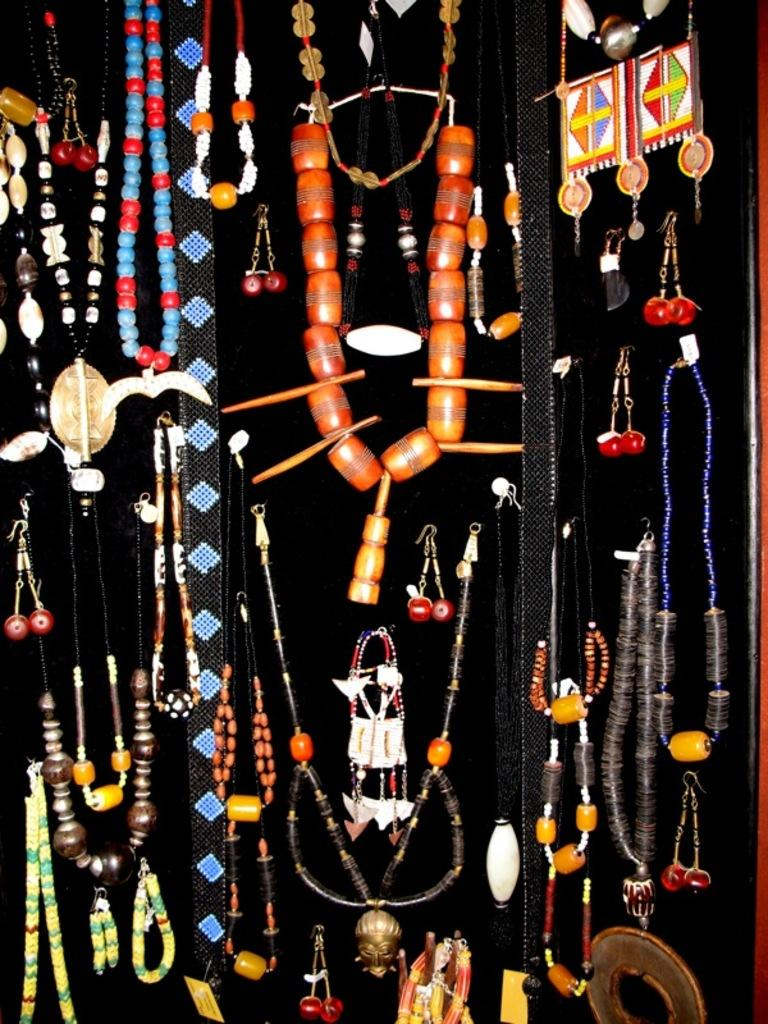What can be seen in the image? There are ornaments in the image. Can you describe the ornaments? The ornaments are of different types. What is the condition of the linen in the image? There is no linen present in the image; it only features ornaments. Can you see any objects related to space in the image? There is no reference to space or any space-related objects in the image; it only features ornaments. 